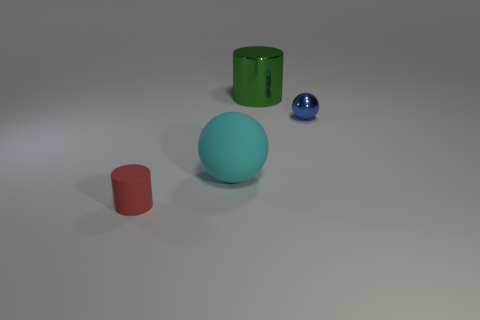Are there more small metallic objects than small purple rubber cylinders?
Provide a short and direct response. Yes. What material is the small red thing that is the same shape as the green thing?
Keep it short and to the point. Rubber. Are the large sphere and the red cylinder made of the same material?
Provide a succinct answer. Yes. Are there more balls that are to the right of the large metal cylinder than big green metallic cylinders?
Your answer should be compact. No. There is a tiny object that is in front of the ball in front of the tiny object right of the big green thing; what is it made of?
Offer a very short reply. Rubber. How many things are big metallic cylinders or cylinders behind the small red matte cylinder?
Provide a succinct answer. 1. Is the color of the cylinder in front of the big ball the same as the large rubber object?
Your response must be concise. No. Are there more small metal balls that are behind the blue ball than red cylinders to the right of the tiny red matte cylinder?
Give a very brief answer. No. Are there any other things that are the same color as the small sphere?
Ensure brevity in your answer.  No. How many objects are either large purple blocks or red rubber things?
Keep it short and to the point. 1. 